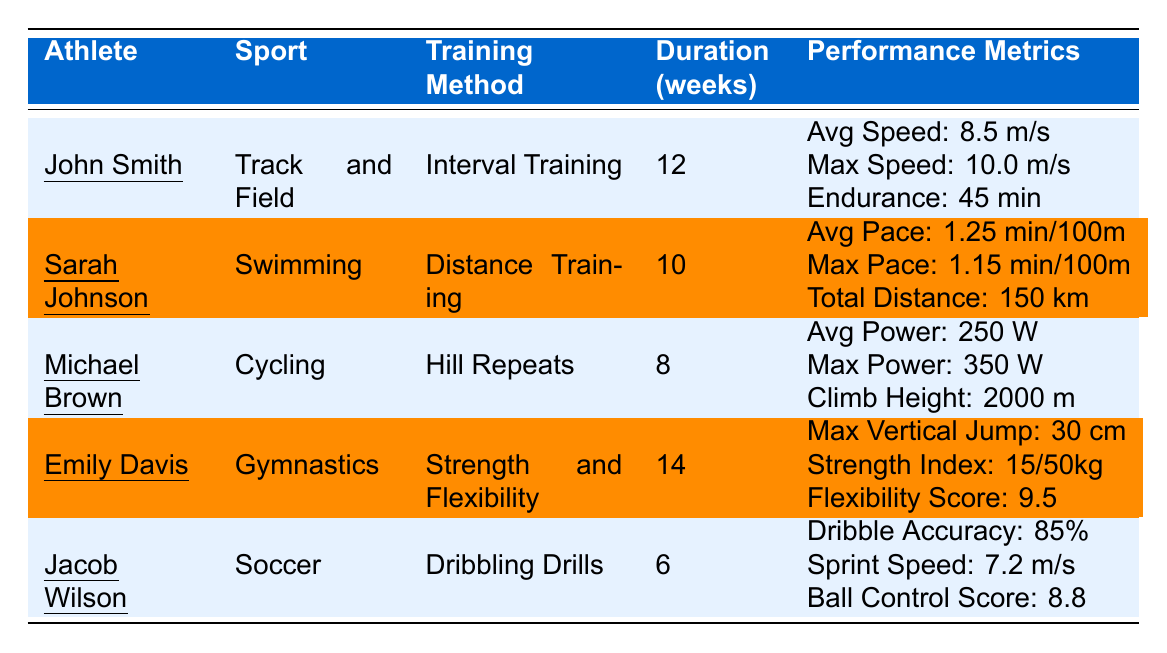What is the training method used by Emily Davis? In the table, under Emily Davis's row, the column for Training Method indicates "Strength and Flexibility".
Answer: Strength and Flexibility Which athlete participated in the longest training duration, and how many weeks did they train? The table lists Emily Davis with a training duration of 14 weeks, which is more than any other athlete.
Answer: Emily Davis, 14 weeks What was John Smith's average speed in meters per second? According to the data in John Smith's row, the Average Speed is noted as 8.5 m/s.
Answer: 8.5 m/s Calculate the average sprint speed of the athletes listed in the table. John Smith has 8.5 m/s, Jacob Wilson has 7.2 m/s, and there are no other sprint speed metrics given. To find the average, add the two values: (8.5 + 7.2) / 2 = 7.85 m/s.
Answer: 7.85 m/s Did Michael Brown achieve a maximum power output greater than 300 watts? In the row for Michael Brown, his Max Power Output is listed as 350 watts, indicating that it is indeed greater than 300 watts.
Answer: Yes Which athlete had the highest vertical jump, and what was the height? Emily Davis's Max Vertical Jump is recorded as 30 cm, and there are no other vertical jumps listed. Therefore, she had the highest.
Answer: Emily Davis, 30 cm What is the total distance swum by Sarah Johnson during her training? The table specifies that Sarah Johnson swam a Total Distance of 150 km, which is directly stated in her row.
Answer: 150 km If we compare the endurance of John Smith and Jacob Wilson, who had longer endurance training? John Smith's endurance is listed as 45 minutes, while Jacob Wilson does not have an endurance metric listed, thus John has the longer endurance training.
Answer: John Smith Were Emily Davis's Strength Index and Flexibility Score metrics higher than John Smith's endurance metric? Emily Davis's Strength Index is 15/50 kg, and her Flexibility Score is 9.5. John Smith’s endurance is noted as 45 minutes. The comparison of different metric types makes this a non-comparable situation, but endurance is not greater than both fitness metrics.
Answer: No What is the difference between the Maximum Speed of John Smith and the Average Power Output of Michael Brown? John Smith's Maximum Speed is 10 m/s, and Michael Brown's Average Power Output is 250 W. Since different types of performance metrics cannot be directly compared, the question does not apply.
Answer: Not applicable 